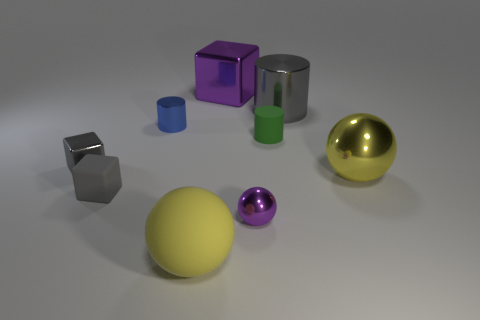Subtract all metallic spheres. How many spheres are left? 1 Subtract all spheres. How many objects are left? 6 Subtract 2 blocks. How many blocks are left? 1 Subtract all gray cubes. How many cubes are left? 1 Add 1 gray metal cylinders. How many objects exist? 10 Subtract 0 gray spheres. How many objects are left? 9 Subtract all purple cubes. Subtract all gray cylinders. How many cubes are left? 2 Subtract all yellow cylinders. How many yellow blocks are left? 0 Subtract all green cylinders. Subtract all gray rubber objects. How many objects are left? 7 Add 5 purple shiny cubes. How many purple shiny cubes are left? 6 